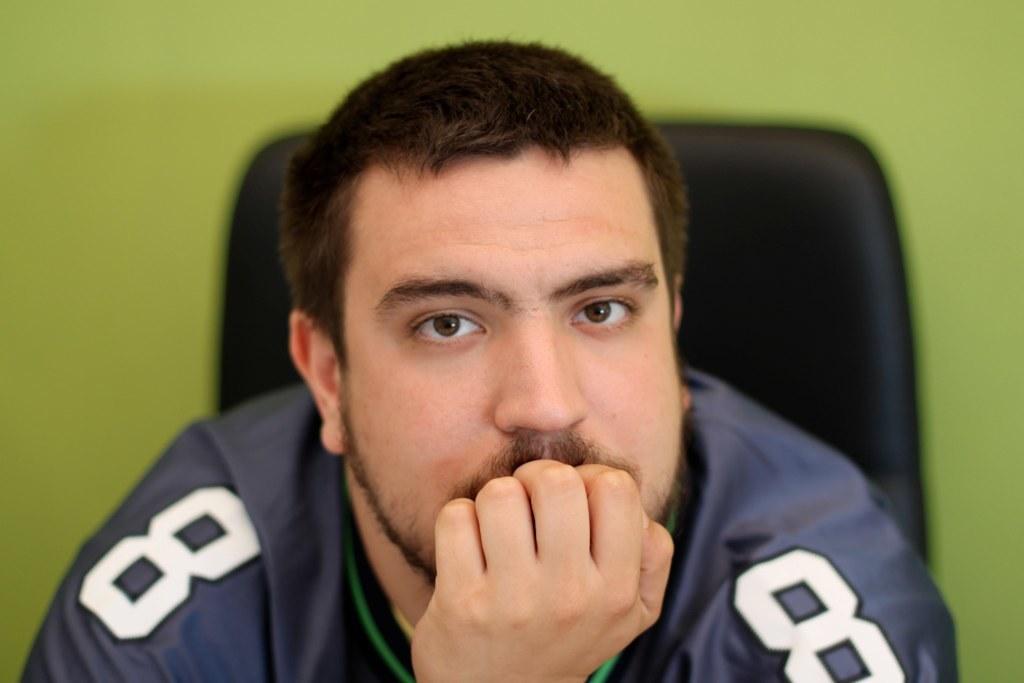How would you summarize this image in a sentence or two? In this image I can see a person wearing green, blue and white colored dress is sitting on a chair which is black in color. I can see the green colored background. 